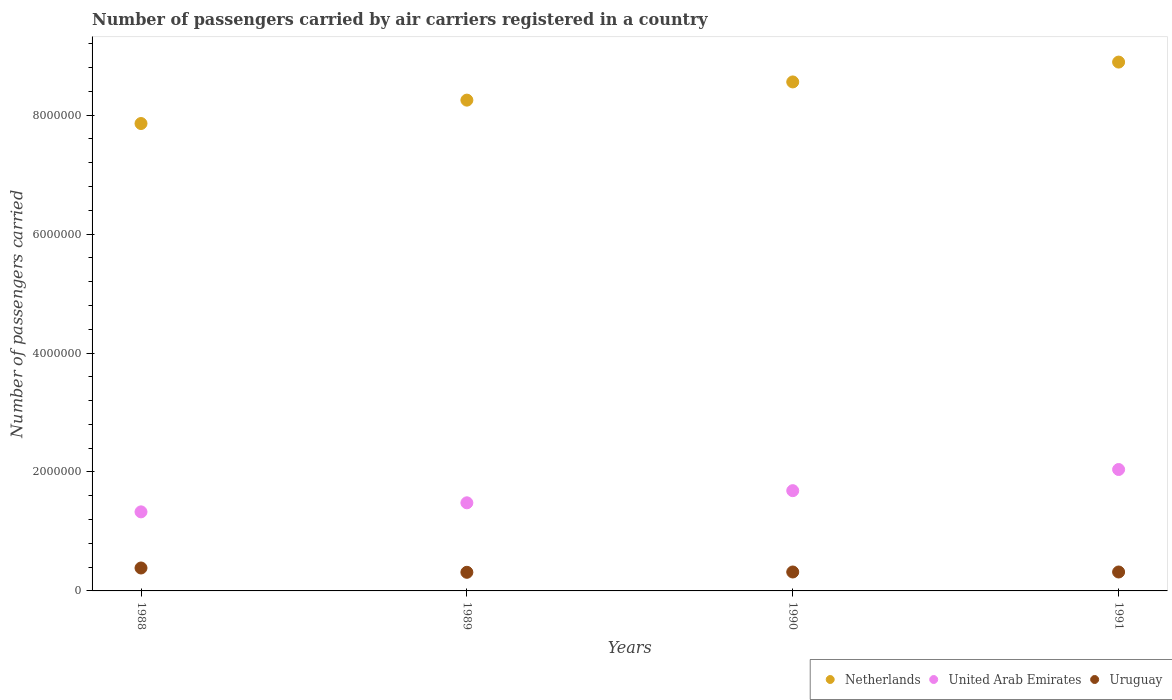What is the number of passengers carried by air carriers in Netherlands in 1991?
Keep it short and to the point. 8.89e+06. Across all years, what is the maximum number of passengers carried by air carriers in United Arab Emirates?
Offer a terse response. 2.04e+06. Across all years, what is the minimum number of passengers carried by air carriers in United Arab Emirates?
Your answer should be compact. 1.33e+06. What is the total number of passengers carried by air carriers in Netherlands in the graph?
Offer a very short reply. 3.36e+07. What is the difference between the number of passengers carried by air carriers in Netherlands in 1988 and that in 1991?
Your answer should be compact. -1.03e+06. What is the difference between the number of passengers carried by air carriers in Netherlands in 1991 and the number of passengers carried by air carriers in United Arab Emirates in 1988?
Offer a very short reply. 7.56e+06. What is the average number of passengers carried by air carriers in Uruguay per year?
Your response must be concise. 3.34e+05. In the year 1991, what is the difference between the number of passengers carried by air carriers in Uruguay and number of passengers carried by air carriers in Netherlands?
Give a very brief answer. -8.57e+06. What is the ratio of the number of passengers carried by air carriers in Uruguay in 1988 to that in 1991?
Ensure brevity in your answer.  1.21. Is the number of passengers carried by air carriers in Uruguay in 1988 less than that in 1991?
Your answer should be very brief. No. What is the difference between the highest and the second highest number of passengers carried by air carriers in Uruguay?
Provide a succinct answer. 6.73e+04. What is the difference between the highest and the lowest number of passengers carried by air carriers in United Arab Emirates?
Make the answer very short. 7.12e+05. Is the sum of the number of passengers carried by air carriers in United Arab Emirates in 1988 and 1990 greater than the maximum number of passengers carried by air carriers in Uruguay across all years?
Your answer should be compact. Yes. Is it the case that in every year, the sum of the number of passengers carried by air carriers in United Arab Emirates and number of passengers carried by air carriers in Netherlands  is greater than the number of passengers carried by air carriers in Uruguay?
Your response must be concise. Yes. Does the number of passengers carried by air carriers in Netherlands monotonically increase over the years?
Keep it short and to the point. Yes. Is the number of passengers carried by air carriers in United Arab Emirates strictly greater than the number of passengers carried by air carriers in Uruguay over the years?
Offer a terse response. Yes. How many years are there in the graph?
Provide a succinct answer. 4. Does the graph contain any zero values?
Ensure brevity in your answer.  No. Does the graph contain grids?
Offer a very short reply. No. How are the legend labels stacked?
Keep it short and to the point. Horizontal. What is the title of the graph?
Provide a short and direct response. Number of passengers carried by air carriers registered in a country. What is the label or title of the Y-axis?
Give a very brief answer. Number of passengers carried. What is the Number of passengers carried of Netherlands in 1988?
Provide a succinct answer. 7.86e+06. What is the Number of passengers carried in United Arab Emirates in 1988?
Make the answer very short. 1.33e+06. What is the Number of passengers carried of Uruguay in 1988?
Provide a succinct answer. 3.86e+05. What is the Number of passengers carried in Netherlands in 1989?
Ensure brevity in your answer.  8.25e+06. What is the Number of passengers carried of United Arab Emirates in 1989?
Provide a succinct answer. 1.48e+06. What is the Number of passengers carried of Uruguay in 1989?
Offer a terse response. 3.13e+05. What is the Number of passengers carried of Netherlands in 1990?
Your answer should be very brief. 8.56e+06. What is the Number of passengers carried of United Arab Emirates in 1990?
Make the answer very short. 1.69e+06. What is the Number of passengers carried of Uruguay in 1990?
Provide a succinct answer. 3.18e+05. What is the Number of passengers carried in Netherlands in 1991?
Your answer should be very brief. 8.89e+06. What is the Number of passengers carried in United Arab Emirates in 1991?
Make the answer very short. 2.04e+06. What is the Number of passengers carried in Uruguay in 1991?
Offer a terse response. 3.18e+05. Across all years, what is the maximum Number of passengers carried of Netherlands?
Your answer should be very brief. 8.89e+06. Across all years, what is the maximum Number of passengers carried in United Arab Emirates?
Your answer should be very brief. 2.04e+06. Across all years, what is the maximum Number of passengers carried of Uruguay?
Give a very brief answer. 3.86e+05. Across all years, what is the minimum Number of passengers carried in Netherlands?
Provide a short and direct response. 7.86e+06. Across all years, what is the minimum Number of passengers carried in United Arab Emirates?
Offer a terse response. 1.33e+06. Across all years, what is the minimum Number of passengers carried in Uruguay?
Offer a terse response. 3.13e+05. What is the total Number of passengers carried of Netherlands in the graph?
Provide a succinct answer. 3.36e+07. What is the total Number of passengers carried of United Arab Emirates in the graph?
Provide a short and direct response. 6.54e+06. What is the total Number of passengers carried of Uruguay in the graph?
Offer a very short reply. 1.34e+06. What is the difference between the Number of passengers carried in Netherlands in 1988 and that in 1989?
Provide a succinct answer. -3.93e+05. What is the difference between the Number of passengers carried in United Arab Emirates in 1988 and that in 1989?
Make the answer very short. -1.52e+05. What is the difference between the Number of passengers carried of Uruguay in 1988 and that in 1989?
Make the answer very short. 7.25e+04. What is the difference between the Number of passengers carried in Netherlands in 1988 and that in 1990?
Make the answer very short. -6.99e+05. What is the difference between the Number of passengers carried in United Arab Emirates in 1988 and that in 1990?
Provide a short and direct response. -3.56e+05. What is the difference between the Number of passengers carried of Uruguay in 1988 and that in 1990?
Your response must be concise. 6.73e+04. What is the difference between the Number of passengers carried in Netherlands in 1988 and that in 1991?
Provide a short and direct response. -1.03e+06. What is the difference between the Number of passengers carried of United Arab Emirates in 1988 and that in 1991?
Your response must be concise. -7.12e+05. What is the difference between the Number of passengers carried in Uruguay in 1988 and that in 1991?
Offer a very short reply. 6.73e+04. What is the difference between the Number of passengers carried of Netherlands in 1989 and that in 1990?
Offer a very short reply. -3.06e+05. What is the difference between the Number of passengers carried of United Arab Emirates in 1989 and that in 1990?
Your response must be concise. -2.04e+05. What is the difference between the Number of passengers carried of Uruguay in 1989 and that in 1990?
Give a very brief answer. -5200. What is the difference between the Number of passengers carried of Netherlands in 1989 and that in 1991?
Offer a terse response. -6.40e+05. What is the difference between the Number of passengers carried of United Arab Emirates in 1989 and that in 1991?
Keep it short and to the point. -5.60e+05. What is the difference between the Number of passengers carried in Uruguay in 1989 and that in 1991?
Your answer should be very brief. -5200. What is the difference between the Number of passengers carried of Netherlands in 1990 and that in 1991?
Offer a very short reply. -3.34e+05. What is the difference between the Number of passengers carried in United Arab Emirates in 1990 and that in 1991?
Your answer should be compact. -3.56e+05. What is the difference between the Number of passengers carried of Netherlands in 1988 and the Number of passengers carried of United Arab Emirates in 1989?
Your response must be concise. 6.38e+06. What is the difference between the Number of passengers carried of Netherlands in 1988 and the Number of passengers carried of Uruguay in 1989?
Provide a succinct answer. 7.55e+06. What is the difference between the Number of passengers carried of United Arab Emirates in 1988 and the Number of passengers carried of Uruguay in 1989?
Ensure brevity in your answer.  1.02e+06. What is the difference between the Number of passengers carried of Netherlands in 1988 and the Number of passengers carried of United Arab Emirates in 1990?
Provide a succinct answer. 6.17e+06. What is the difference between the Number of passengers carried of Netherlands in 1988 and the Number of passengers carried of Uruguay in 1990?
Ensure brevity in your answer.  7.54e+06. What is the difference between the Number of passengers carried of United Arab Emirates in 1988 and the Number of passengers carried of Uruguay in 1990?
Offer a very short reply. 1.01e+06. What is the difference between the Number of passengers carried of Netherlands in 1988 and the Number of passengers carried of United Arab Emirates in 1991?
Make the answer very short. 5.82e+06. What is the difference between the Number of passengers carried in Netherlands in 1988 and the Number of passengers carried in Uruguay in 1991?
Ensure brevity in your answer.  7.54e+06. What is the difference between the Number of passengers carried of United Arab Emirates in 1988 and the Number of passengers carried of Uruguay in 1991?
Provide a succinct answer. 1.01e+06. What is the difference between the Number of passengers carried in Netherlands in 1989 and the Number of passengers carried in United Arab Emirates in 1990?
Keep it short and to the point. 6.57e+06. What is the difference between the Number of passengers carried in Netherlands in 1989 and the Number of passengers carried in Uruguay in 1990?
Your response must be concise. 7.94e+06. What is the difference between the Number of passengers carried in United Arab Emirates in 1989 and the Number of passengers carried in Uruguay in 1990?
Offer a terse response. 1.16e+06. What is the difference between the Number of passengers carried in Netherlands in 1989 and the Number of passengers carried in United Arab Emirates in 1991?
Your answer should be very brief. 6.21e+06. What is the difference between the Number of passengers carried in Netherlands in 1989 and the Number of passengers carried in Uruguay in 1991?
Make the answer very short. 7.94e+06. What is the difference between the Number of passengers carried in United Arab Emirates in 1989 and the Number of passengers carried in Uruguay in 1991?
Your answer should be very brief. 1.16e+06. What is the difference between the Number of passengers carried of Netherlands in 1990 and the Number of passengers carried of United Arab Emirates in 1991?
Your answer should be compact. 6.52e+06. What is the difference between the Number of passengers carried of Netherlands in 1990 and the Number of passengers carried of Uruguay in 1991?
Your response must be concise. 8.24e+06. What is the difference between the Number of passengers carried of United Arab Emirates in 1990 and the Number of passengers carried of Uruguay in 1991?
Provide a short and direct response. 1.37e+06. What is the average Number of passengers carried of Netherlands per year?
Your response must be concise. 8.39e+06. What is the average Number of passengers carried of United Arab Emirates per year?
Your answer should be very brief. 1.63e+06. What is the average Number of passengers carried of Uruguay per year?
Make the answer very short. 3.34e+05. In the year 1988, what is the difference between the Number of passengers carried of Netherlands and Number of passengers carried of United Arab Emirates?
Give a very brief answer. 6.53e+06. In the year 1988, what is the difference between the Number of passengers carried of Netherlands and Number of passengers carried of Uruguay?
Ensure brevity in your answer.  7.47e+06. In the year 1988, what is the difference between the Number of passengers carried of United Arab Emirates and Number of passengers carried of Uruguay?
Your answer should be very brief. 9.44e+05. In the year 1989, what is the difference between the Number of passengers carried of Netherlands and Number of passengers carried of United Arab Emirates?
Your response must be concise. 6.77e+06. In the year 1989, what is the difference between the Number of passengers carried in Netherlands and Number of passengers carried in Uruguay?
Ensure brevity in your answer.  7.94e+06. In the year 1989, what is the difference between the Number of passengers carried in United Arab Emirates and Number of passengers carried in Uruguay?
Your answer should be compact. 1.17e+06. In the year 1990, what is the difference between the Number of passengers carried of Netherlands and Number of passengers carried of United Arab Emirates?
Your response must be concise. 6.87e+06. In the year 1990, what is the difference between the Number of passengers carried in Netherlands and Number of passengers carried in Uruguay?
Provide a short and direct response. 8.24e+06. In the year 1990, what is the difference between the Number of passengers carried in United Arab Emirates and Number of passengers carried in Uruguay?
Your answer should be very brief. 1.37e+06. In the year 1991, what is the difference between the Number of passengers carried in Netherlands and Number of passengers carried in United Arab Emirates?
Make the answer very short. 6.85e+06. In the year 1991, what is the difference between the Number of passengers carried in Netherlands and Number of passengers carried in Uruguay?
Give a very brief answer. 8.57e+06. In the year 1991, what is the difference between the Number of passengers carried of United Arab Emirates and Number of passengers carried of Uruguay?
Offer a terse response. 1.72e+06. What is the ratio of the Number of passengers carried in Netherlands in 1988 to that in 1989?
Your answer should be very brief. 0.95. What is the ratio of the Number of passengers carried of United Arab Emirates in 1988 to that in 1989?
Make the answer very short. 0.9. What is the ratio of the Number of passengers carried in Uruguay in 1988 to that in 1989?
Keep it short and to the point. 1.23. What is the ratio of the Number of passengers carried in Netherlands in 1988 to that in 1990?
Make the answer very short. 0.92. What is the ratio of the Number of passengers carried of United Arab Emirates in 1988 to that in 1990?
Keep it short and to the point. 0.79. What is the ratio of the Number of passengers carried of Uruguay in 1988 to that in 1990?
Your answer should be compact. 1.21. What is the ratio of the Number of passengers carried of Netherlands in 1988 to that in 1991?
Provide a short and direct response. 0.88. What is the ratio of the Number of passengers carried of United Arab Emirates in 1988 to that in 1991?
Your answer should be compact. 0.65. What is the ratio of the Number of passengers carried in Uruguay in 1988 to that in 1991?
Offer a very short reply. 1.21. What is the ratio of the Number of passengers carried of Netherlands in 1989 to that in 1990?
Offer a terse response. 0.96. What is the ratio of the Number of passengers carried in United Arab Emirates in 1989 to that in 1990?
Give a very brief answer. 0.88. What is the ratio of the Number of passengers carried in Uruguay in 1989 to that in 1990?
Provide a succinct answer. 0.98. What is the ratio of the Number of passengers carried in Netherlands in 1989 to that in 1991?
Your response must be concise. 0.93. What is the ratio of the Number of passengers carried in United Arab Emirates in 1989 to that in 1991?
Your answer should be compact. 0.73. What is the ratio of the Number of passengers carried in Uruguay in 1989 to that in 1991?
Give a very brief answer. 0.98. What is the ratio of the Number of passengers carried in Netherlands in 1990 to that in 1991?
Ensure brevity in your answer.  0.96. What is the ratio of the Number of passengers carried in United Arab Emirates in 1990 to that in 1991?
Your answer should be compact. 0.83. What is the ratio of the Number of passengers carried of Uruguay in 1990 to that in 1991?
Make the answer very short. 1. What is the difference between the highest and the second highest Number of passengers carried of Netherlands?
Give a very brief answer. 3.34e+05. What is the difference between the highest and the second highest Number of passengers carried of United Arab Emirates?
Make the answer very short. 3.56e+05. What is the difference between the highest and the second highest Number of passengers carried of Uruguay?
Ensure brevity in your answer.  6.73e+04. What is the difference between the highest and the lowest Number of passengers carried of Netherlands?
Make the answer very short. 1.03e+06. What is the difference between the highest and the lowest Number of passengers carried in United Arab Emirates?
Give a very brief answer. 7.12e+05. What is the difference between the highest and the lowest Number of passengers carried in Uruguay?
Keep it short and to the point. 7.25e+04. 